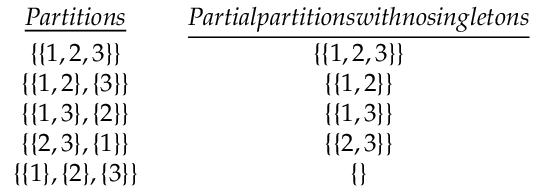Convert formula to latex. <formula><loc_0><loc_0><loc_500><loc_500>\begin{array} { r } { \begin{array} { c c c } { \underline { P a r t i t i o n s } } & & { \underline { P a r t i a l p a r t i t i o n s w i t h n o \sin g l e t o n s } } \\ { \{ \{ 1 , 2 , 3 \} \} } & & { \{ \{ 1 , 2 , 3 \} \} } \\ { \{ \{ 1 , 2 \} , \{ 3 \} \} } & & { \{ \{ 1 , 2 \} \} } \\ { \{ \{ 1 , 3 \} , \{ 2 \} \} } & & { \{ \{ 1 , 3 \} \} } \\ { \{ \{ 2 , 3 \} , \{ 1 \} \} } & & { \{ \{ 2 , 3 \} \} } \\ { \{ \{ 1 \} , \{ 2 \} , \{ 3 \} \} } & & { \{ \} } \end{array} } \end{array}</formula> 